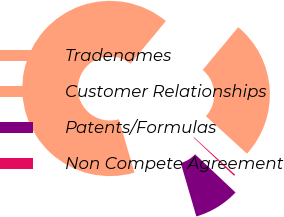<chart> <loc_0><loc_0><loc_500><loc_500><pie_chart><fcel>Tradenames<fcel>Customer Relationships<fcel>Patents/Formulas<fcel>Non Compete Agreement<nl><fcel>25.74%<fcel>65.54%<fcel>8.44%<fcel>0.27%<nl></chart> 